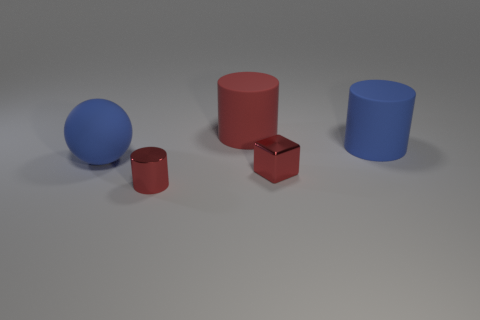Add 1 blue matte things. How many objects exist? 6 Subtract all blocks. How many objects are left? 4 Add 3 matte objects. How many matte objects exist? 6 Subtract 2 red cylinders. How many objects are left? 3 Subtract all tiny brown metallic spheres. Subtract all large balls. How many objects are left? 4 Add 3 small red cubes. How many small red cubes are left? 4 